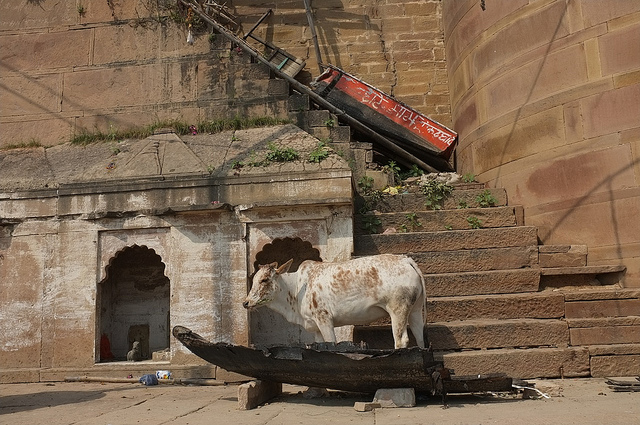Is this a normal place for a cow to be?
Answer the question using a single word or phrase. No What color is the cow? White and brown What is the cow standing on? Boat 